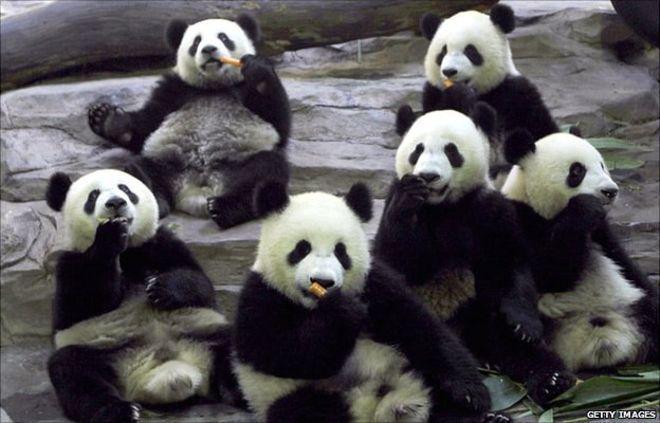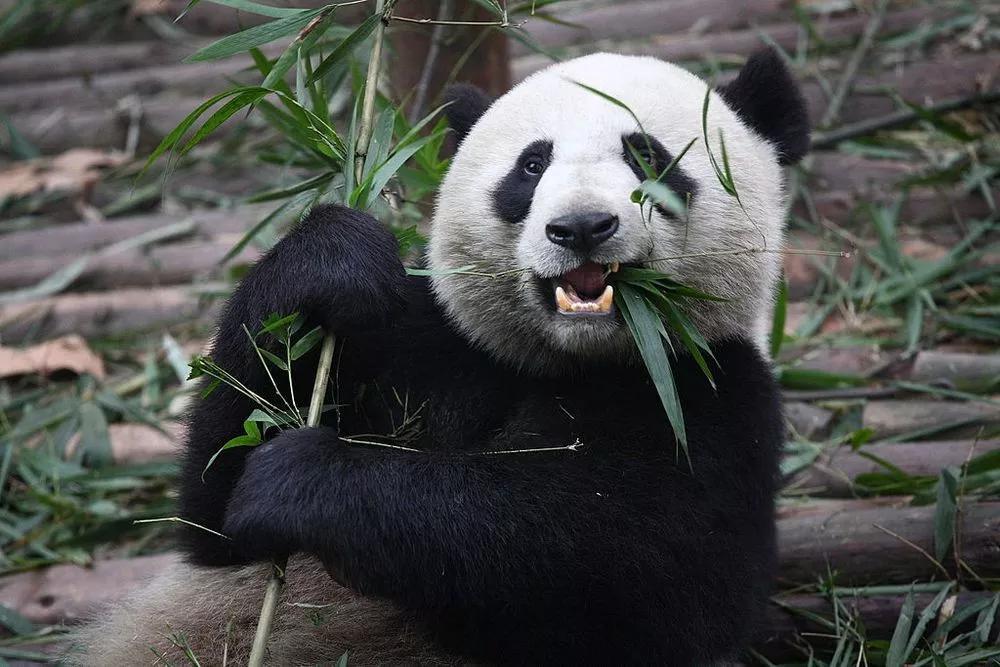The first image is the image on the left, the second image is the image on the right. For the images displayed, is the sentence "The left image contains exactly one panda." factually correct? Answer yes or no. No. The first image is the image on the left, the second image is the image on the right. Evaluate the accuracy of this statement regarding the images: "There are more than 4 pandas.". Is it true? Answer yes or no. Yes. 